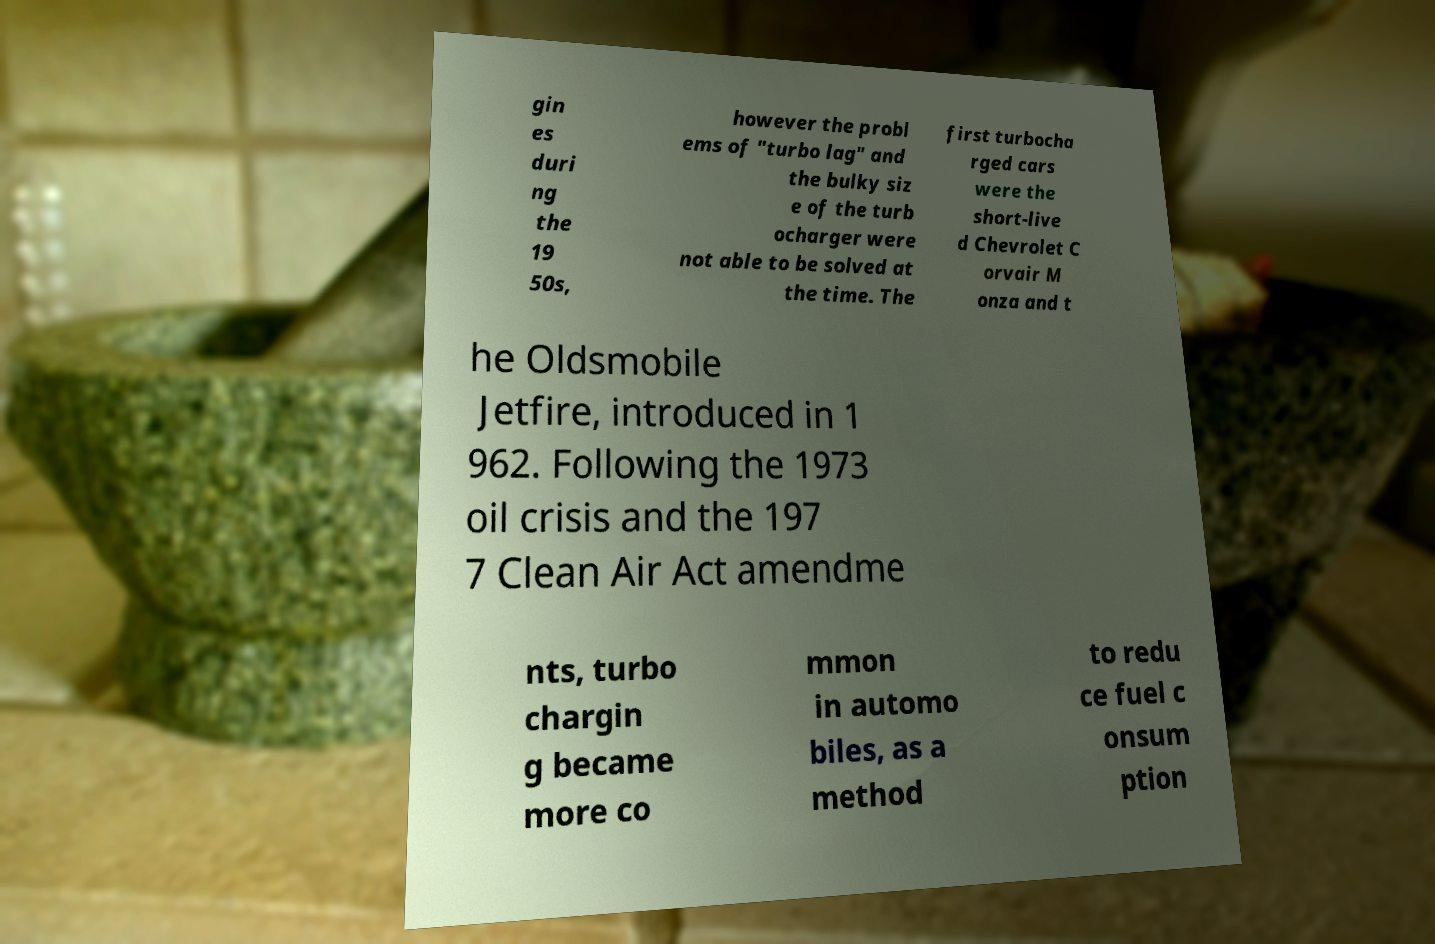Please identify and transcribe the text found in this image. gin es duri ng the 19 50s, however the probl ems of "turbo lag" and the bulky siz e of the turb ocharger were not able to be solved at the time. The first turbocha rged cars were the short-live d Chevrolet C orvair M onza and t he Oldsmobile Jetfire, introduced in 1 962. Following the 1973 oil crisis and the 197 7 Clean Air Act amendme nts, turbo chargin g became more co mmon in automo biles, as a method to redu ce fuel c onsum ption 